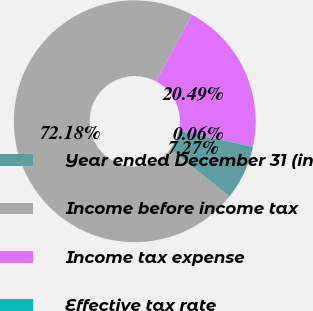<chart> <loc_0><loc_0><loc_500><loc_500><pie_chart><fcel>Year ended December 31 (in<fcel>Income before income tax<fcel>Income tax expense<fcel>Effective tax rate<nl><fcel>7.27%<fcel>72.18%<fcel>20.49%<fcel>0.06%<nl></chart> 